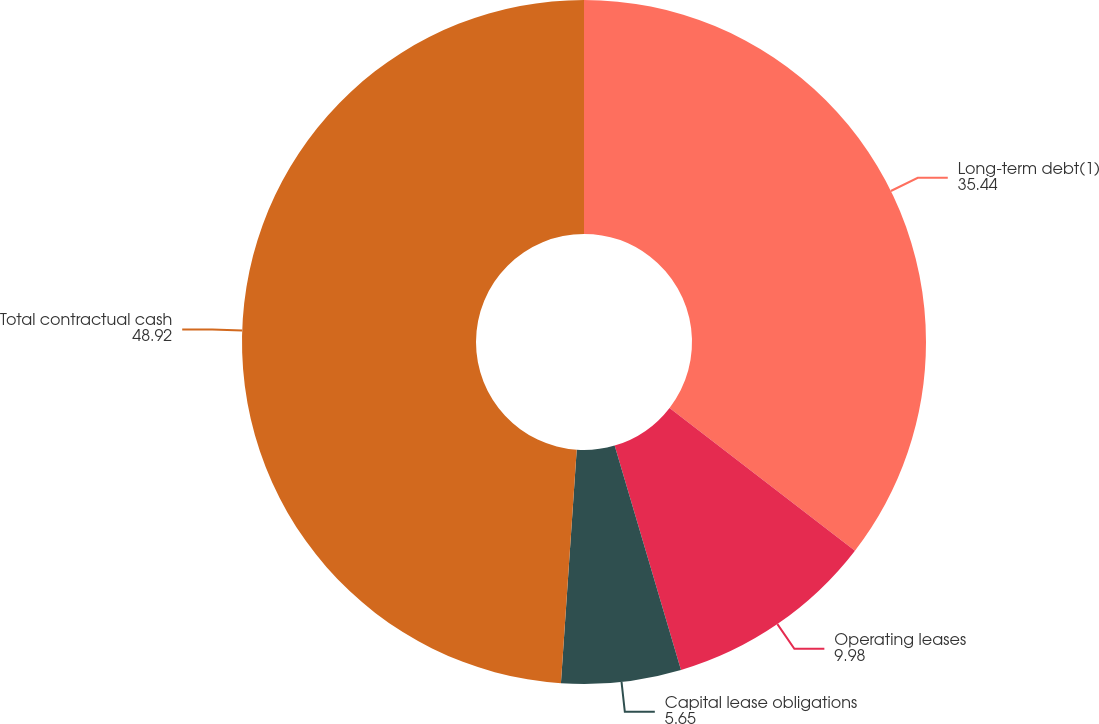Convert chart to OTSL. <chart><loc_0><loc_0><loc_500><loc_500><pie_chart><fcel>Long-term debt(1)<fcel>Operating leases<fcel>Capital lease obligations<fcel>Total contractual cash<nl><fcel>35.44%<fcel>9.98%<fcel>5.65%<fcel>48.92%<nl></chart> 